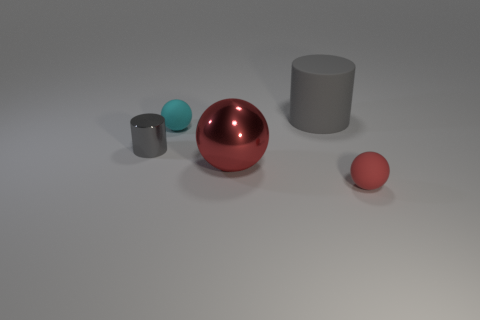Are these objects solid or hollow? Without being able to inspect them physically, it isn't possible to confirm if the objects are solid or hollow, but typically, such objects used in demonstrations or visualizations can be either, depending on their intended use. 